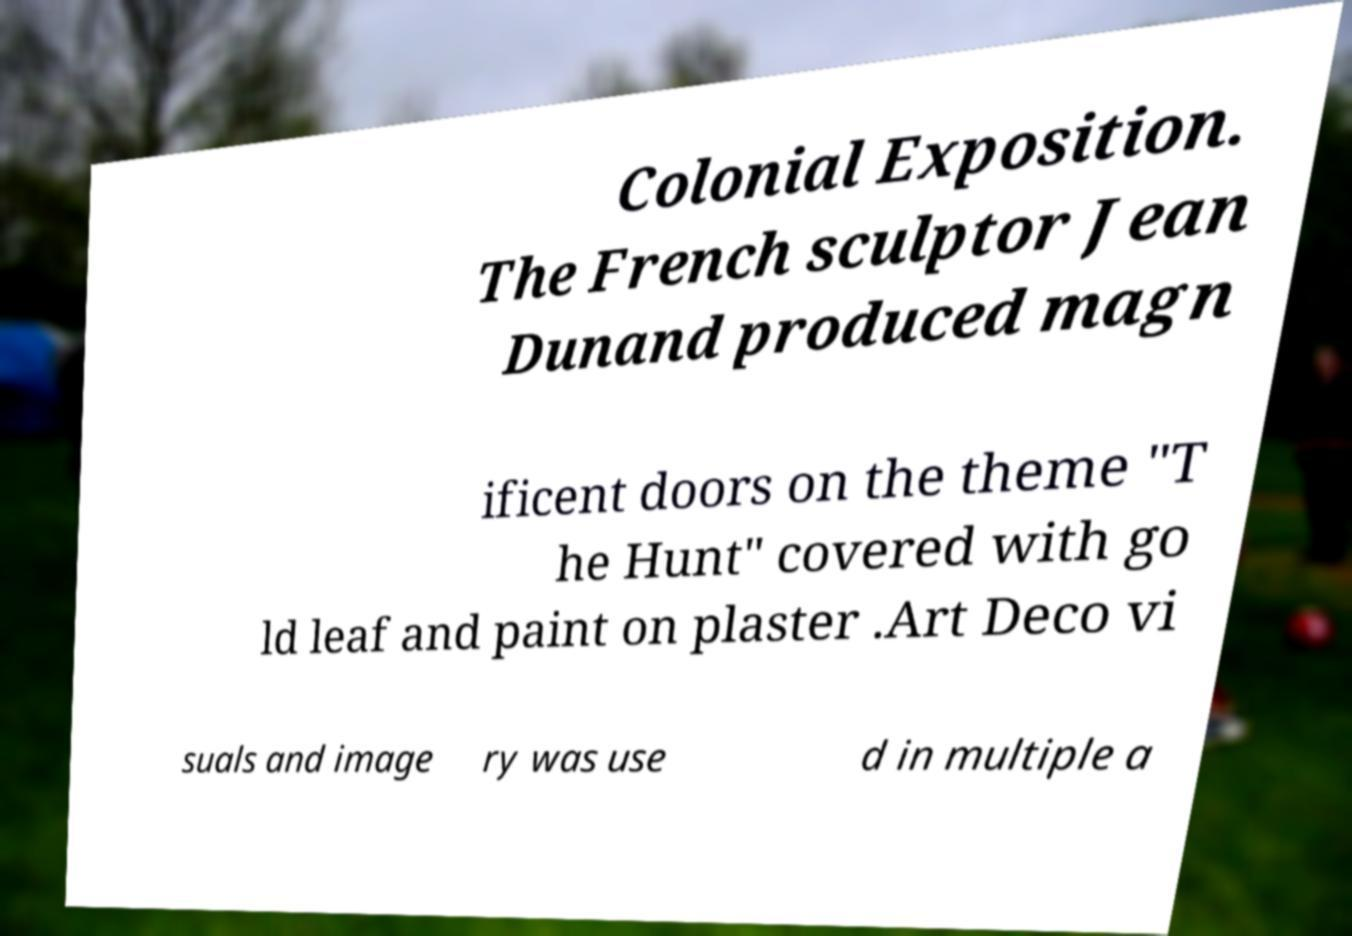For documentation purposes, I need the text within this image transcribed. Could you provide that? Colonial Exposition. The French sculptor Jean Dunand produced magn ificent doors on the theme "T he Hunt" covered with go ld leaf and paint on plaster .Art Deco vi suals and image ry was use d in multiple a 